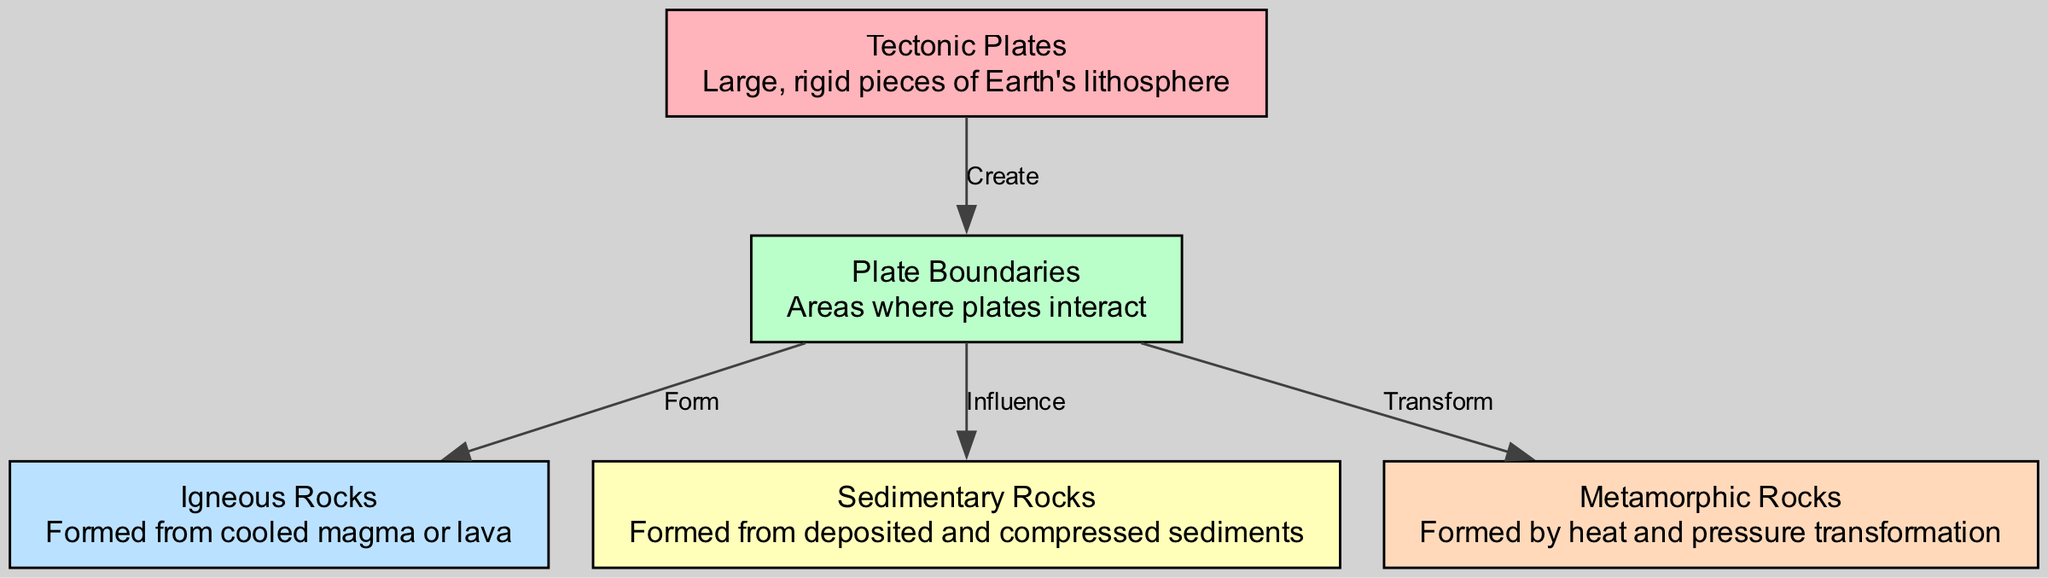What are large, rigid pieces of Earth's lithosphere called? The diagram identifies the "Tectonic Plates" as large, rigid pieces of Earth's lithosphere. This information is found directly in the node labeled "Tectonic Plates."
Answer: Tectonic Plates How many types of rocks are shown in the diagram? The diagram presents three types of rocks: Igneous Rocks, Sedimentary Rocks, and Metamorphic Rocks. Each type is represented in separate nodes, making a total of three types.
Answer: Three What is formed as a result of the interaction at plate boundaries? The diagram illustrates that plate boundaries are responsible for forming Igneous Rocks. The edge labeled "Form" indicates this relationship between "Plate Boundaries" and "Igneous Rocks."
Answer: Igneous Rocks Which type of rock is influenced by plate boundaries? According to the diagram, "Sedimentary Rocks" are influenced by plate boundaries. This is deduced from the edge labeled "Influence" connecting the nodes "Plate Boundaries" and "Sedimentary Rocks."
Answer: Sedimentary Rocks What transformation occurs due to heat and pressure? The diagram specifies that Metamorphic Rocks are formed by transformation due to heat and pressure. This is directly indicated by the edge labeled "Transform" linking "Plate Boundaries" and "Metamorphic Rocks."
Answer: Metamorphic Rocks What do plate boundaries create? The diagram shows that "Tectonic Plates" create "Plate Boundaries." The corresponding edge labeled "Create" demonstrates this connection.
Answer: Plate Boundaries Which type of rocks directly results from cooled magma or lava? The diagram clearly indicates that "Igneous Rocks" directly result from cooled magma or lava. This information is inherent in the definition provided for "Igneous Rocks" in the respective node.
Answer: Igneous Rocks What is formed by deposited and compressed sediments? The diagram describes "Sedimentary Rocks" as being formed from deposited and compressed sediments. This definition is stated in the node related to Sedimentary Rocks.
Answer: Sedimentary Rocks What type of boundary is crucial for rock formation according to the diagram? The diagram emphasizes that "Plate Boundaries" are crucial for the formation of different types of rocks, as they interact to influence rock types. Both the edges and nodes relate to this significance.
Answer: Plate Boundaries 